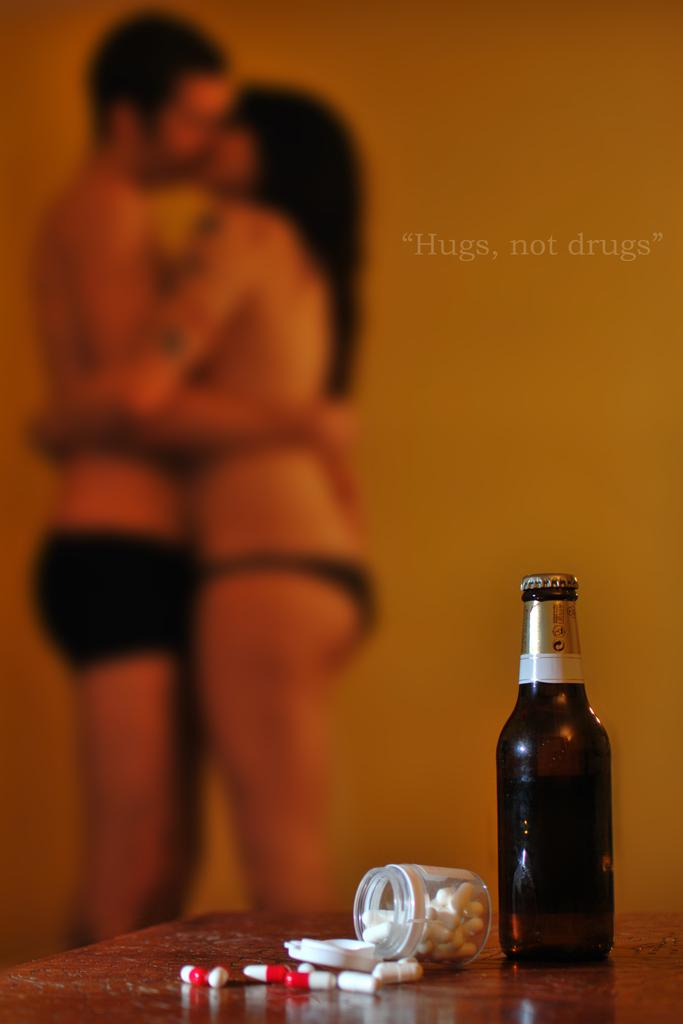What can be seen in the background of the image? There is a wall in the image. How many people are present in the image? There are two people in the image. What furniture is visible in the image? There is a table in the image. What items are on the table? There is a bottle, a box, and tablets on the table. Which direction does the committee face in the image? There is no committee present in the image, so it is not possible to determine the direction they might be facing. What type of land is visible in the image? There is no land visible in the image; it features a wall, a table, and various objects. 